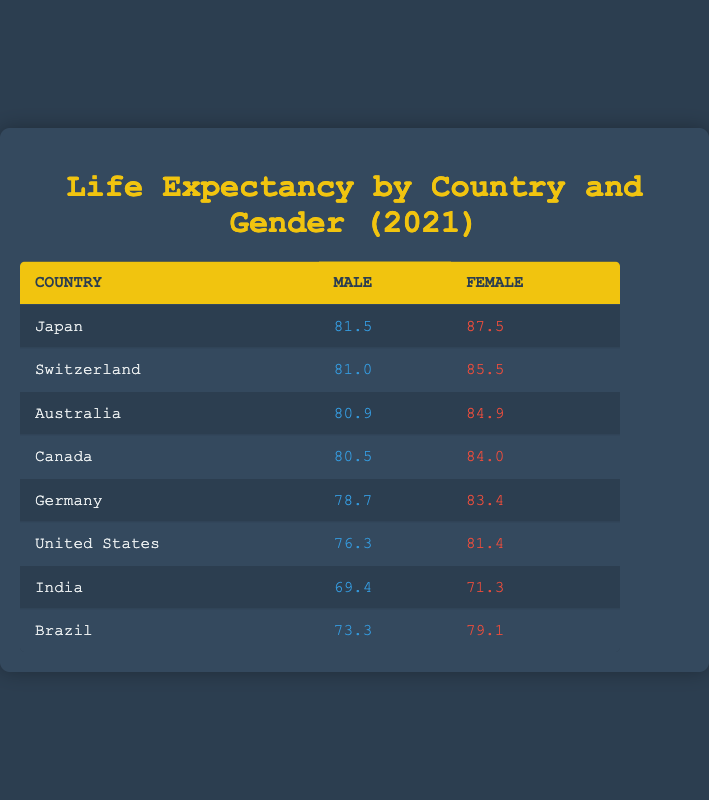What is the life expectancy for females in Japan? The table shows that the life expectancy for females in Japan is listed as 87.5.
Answer: 87.5 Which country has the highest life expectancy for males? In the table, Japan has the highest life expectancy for males, which is 81.5.
Answer: Japan What is the difference in life expectancy between males and females in Canada? The life expectancy for males in Canada is 80.5 and for females is 84.0. The difference is calculated as 84.0 - 80.5 = 3.5.
Answer: 3.5 True or False: The life expectancy of females in the United States is higher than that of males in India. The table indicates that the life expectancy for females in the United States is 81.4 and for males in India is 69.4. Since 81.4 is greater than 69.4, the statement is true.
Answer: True What is the average life expectancy for males across all the countries listed? To find the average, we first sum the male life expectancies: 81.5 + 81.0 + 80.9 + 80.5 + 78.7 + 76.3 + 69.4 + 73.3 =  622.2. There are 8 countries, so we divide by 8: 622.2 / 8 = 77.775.
Answer: 77.775 